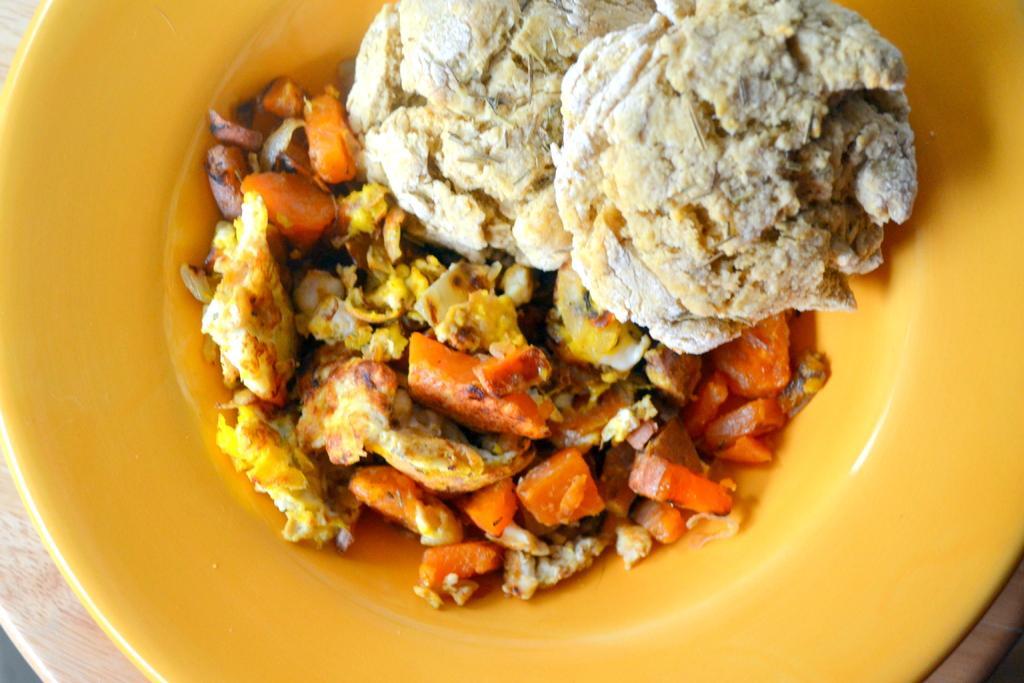Please provide a concise description of this image. In this image I can see a yellow colour plate and on it I can see different types of food. I can see colour of food is white, orange and yellow. 